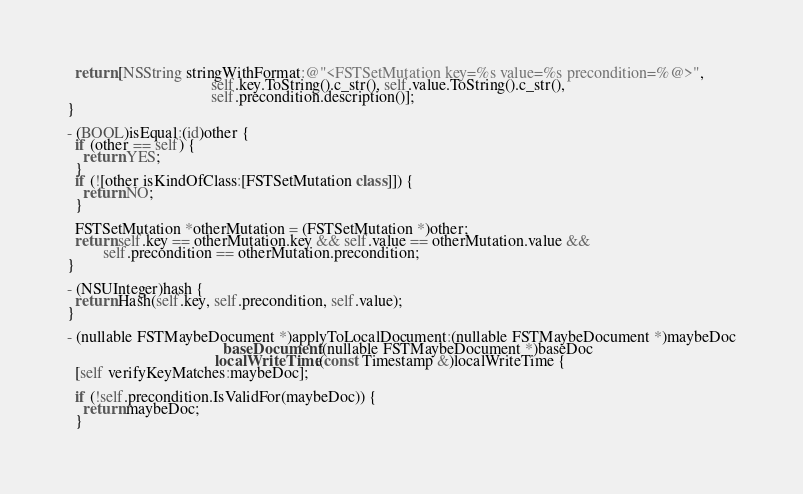<code> <loc_0><loc_0><loc_500><loc_500><_ObjectiveC_>  return [NSString stringWithFormat:@"<FSTSetMutation key=%s value=%s precondition=%@>",
                                    self.key.ToString().c_str(), self.value.ToString().c_str(),
                                    self.precondition.description()];
}

- (BOOL)isEqual:(id)other {
  if (other == self) {
    return YES;
  }
  if (![other isKindOfClass:[FSTSetMutation class]]) {
    return NO;
  }

  FSTSetMutation *otherMutation = (FSTSetMutation *)other;
  return self.key == otherMutation.key && self.value == otherMutation.value &&
         self.precondition == otherMutation.precondition;
}

- (NSUInteger)hash {
  return Hash(self.key, self.precondition, self.value);
}

- (nullable FSTMaybeDocument *)applyToLocalDocument:(nullable FSTMaybeDocument *)maybeDoc
                                       baseDocument:(nullable FSTMaybeDocument *)baseDoc
                                     localWriteTime:(const Timestamp &)localWriteTime {
  [self verifyKeyMatches:maybeDoc];

  if (!self.precondition.IsValidFor(maybeDoc)) {
    return maybeDoc;
  }
</code> 